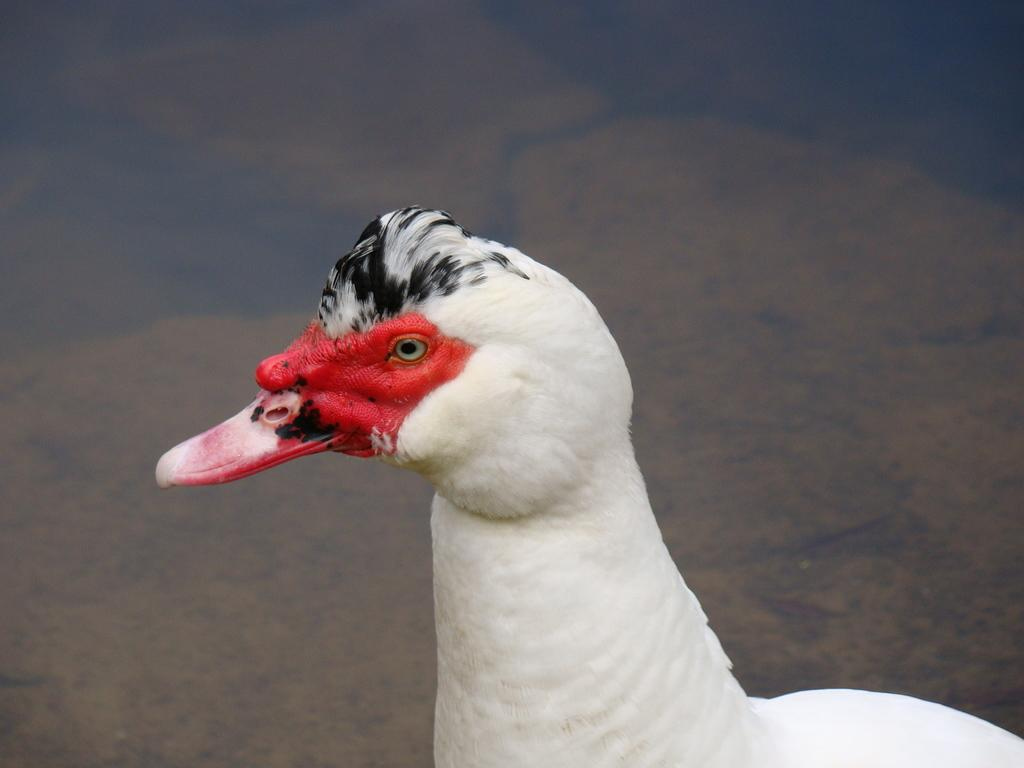What type of animal can be seen in the image? There is a white bird in the image. What type of sand can be seen on the bird's beak in the image? There is no sand present in the image, and the bird's beak is not visible. 